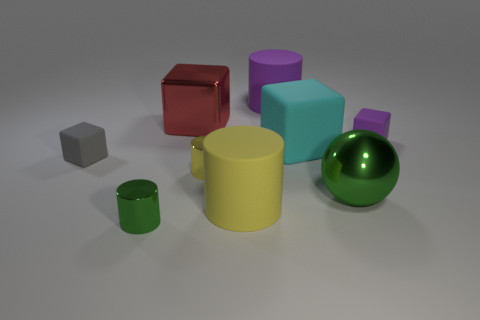Do the big yellow thing and the small purple block have the same material?
Give a very brief answer. Yes. There is a red thing that is the same size as the green sphere; what material is it?
Make the answer very short. Metal. How many things are either tiny objects behind the metallic sphere or cyan rubber things?
Ensure brevity in your answer.  4. Is the number of tiny gray cubes that are to the right of the small yellow thing the same as the number of cyan things?
Give a very brief answer. No. The cylinder that is both in front of the tiny purple thing and behind the big yellow matte cylinder is what color?
Make the answer very short. Yellow. What number of cylinders are either big red things or purple objects?
Offer a very short reply. 1. Are there fewer yellow matte cylinders that are on the left side of the red shiny cube than yellow metal cubes?
Offer a terse response. No. What is the shape of the small yellow object that is made of the same material as the big red block?
Provide a short and direct response. Cylinder. How many metal things have the same color as the large sphere?
Provide a succinct answer. 1. What number of things are small yellow rubber blocks or red shiny blocks?
Keep it short and to the point. 1. 